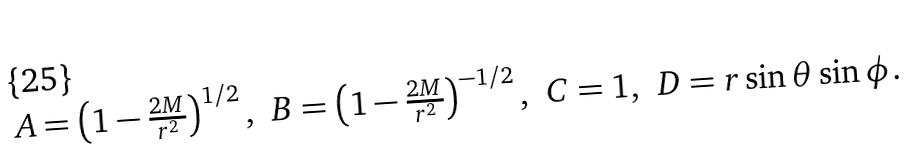Convert formula to latex. <formula><loc_0><loc_0><loc_500><loc_500>\begin{array} { l l l l l l } A = \left ( 1 - \frac { 2 M } { r ^ { 2 } } \right ) ^ { 1 / 2 } , & B = \left ( 1 - \frac { 2 M } { r ^ { 2 } } \right ) ^ { - 1 / 2 } , & C = 1 , & D = r \sin \theta \sin \phi . \\ \end{array}</formula> 